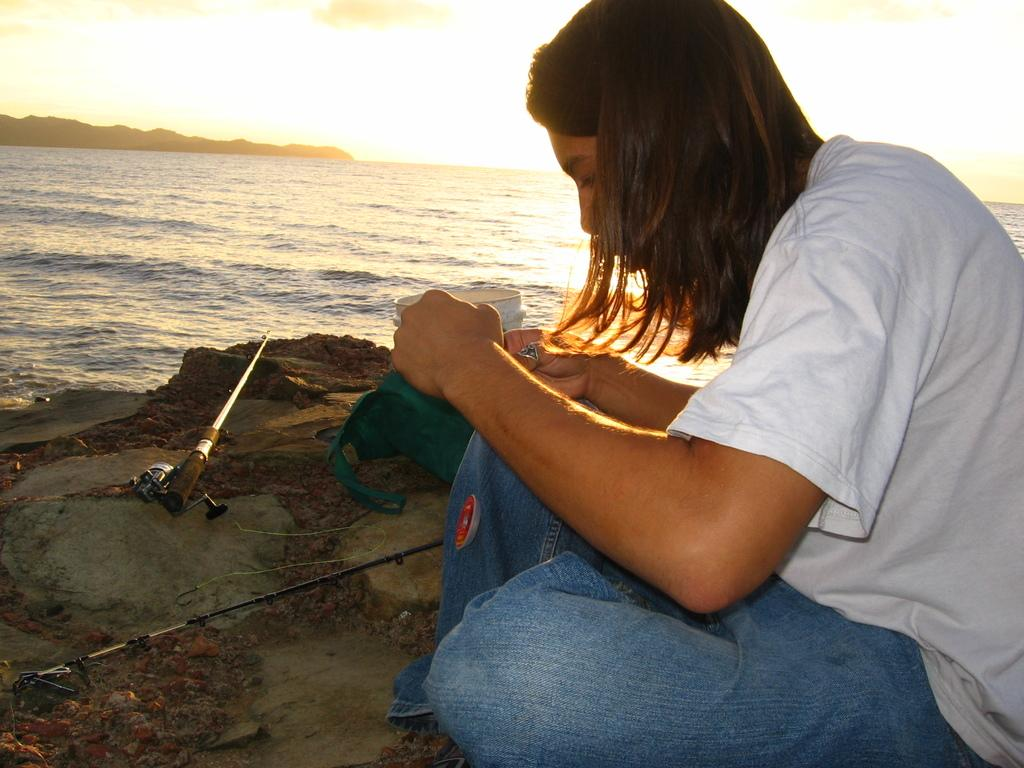Who is present in the image? There is a girl in the image. What is the girl wearing? The girl is wearing a white t-shirt. Where is the girl located in the image? The girl is sitting at the beach side. What is the girl holding in her hand? The girl is holding a blue cloth in her hand. What can be seen in the sky in the image? There is sky visible in the image, and there are clouds in the sky. Can you see a cow grazing on the beach in the image? No, there is no cow present in the image. What type of plastic object is visible on the beach in the image? There is no plastic object visible on the beach in the image. 